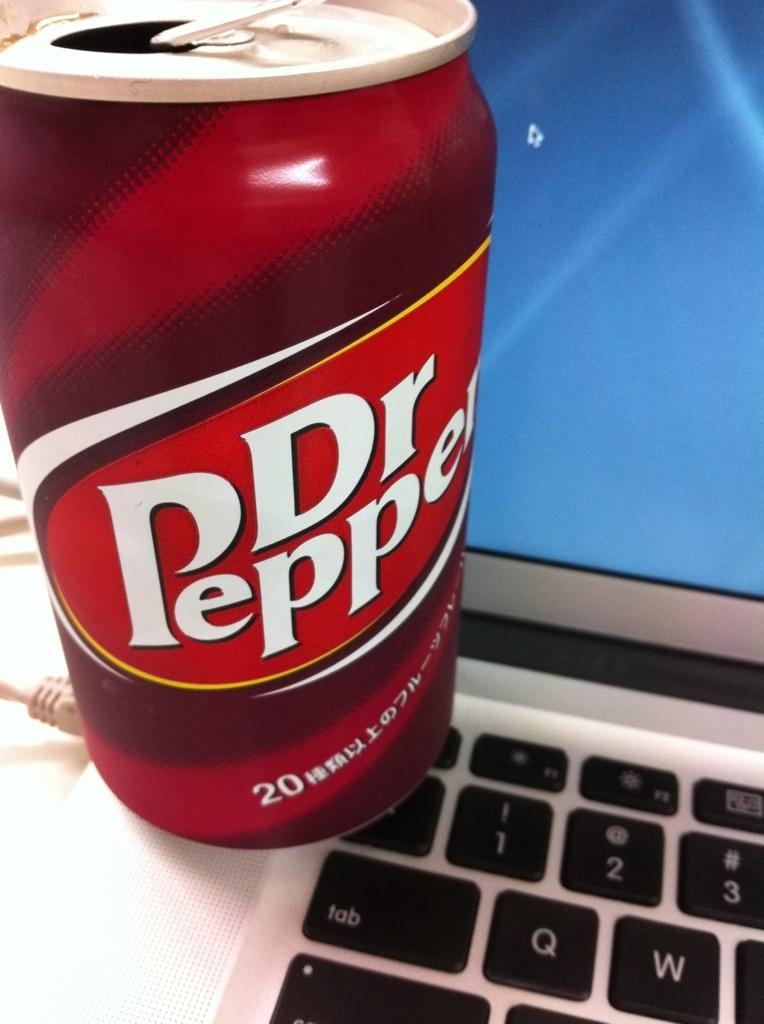Provide a one-sentence caption for the provided image. a bottle of dr pepper and a laptop computer. 